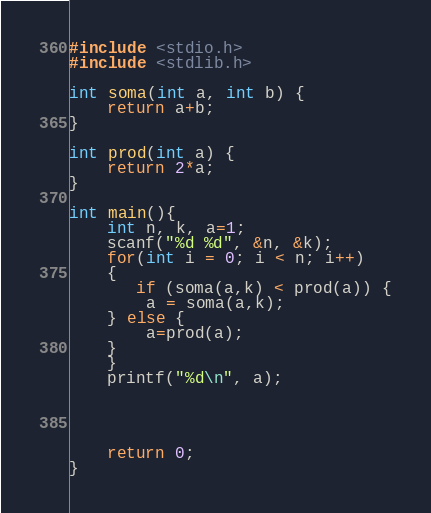Convert code to text. <code><loc_0><loc_0><loc_500><loc_500><_C_>#include <stdio.h>
#include <stdlib.h>

int soma(int a, int b) {
    return a+b;
}

int prod(int a) {
    return 2*a;
}

int main(){
    int n, k, a=1;
    scanf("%d %d", &n, &k);
    for(int i = 0; i < n; i++)
    {
       if (soma(a,k) < prod(a)) {
        a = soma(a,k);
    } else {
        a=prod(a);
    }
    }
    printf("%d\n", a);
    
    


    return 0;
}</code> 